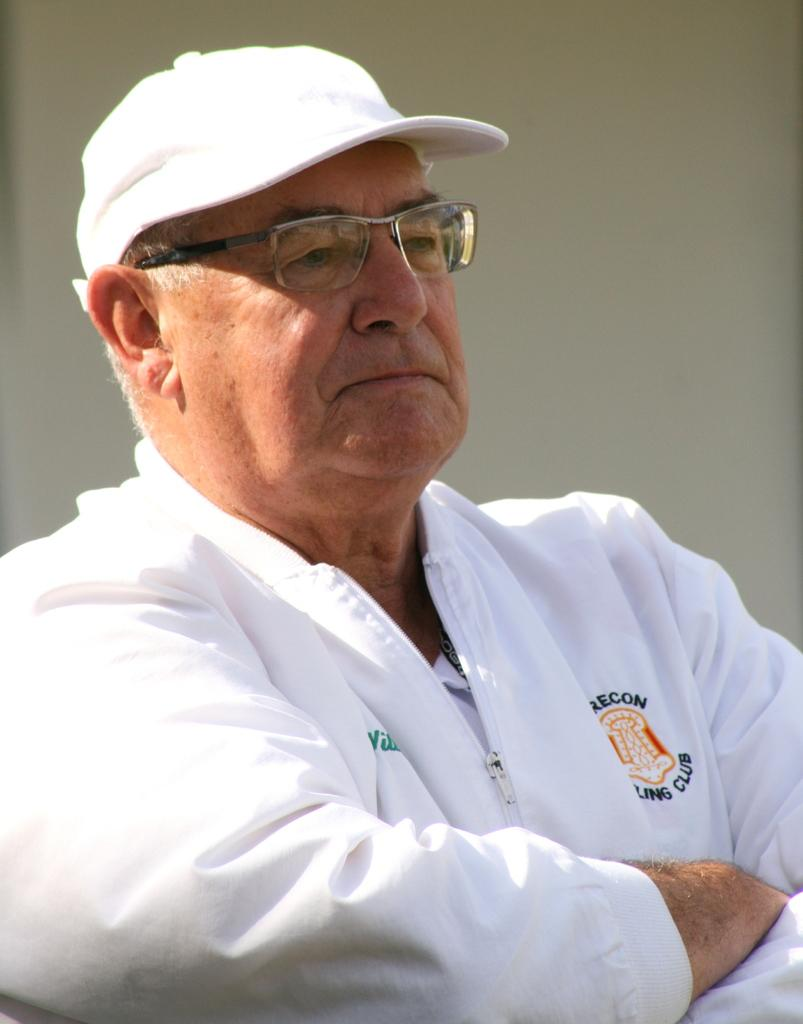Who or what is the main subject in the image? There is a person in the image. Can you describe the person's position in relation to the image? The person is in front. What can be seen behind the person? There is a wall behind the person. What type of chair is the person sitting on in the image? There is no chair present in the image; the person is standing in front of a wall. What rhythm is the person following in the image? There is no indication of rhythm or movement in the image; the person is standing still. 